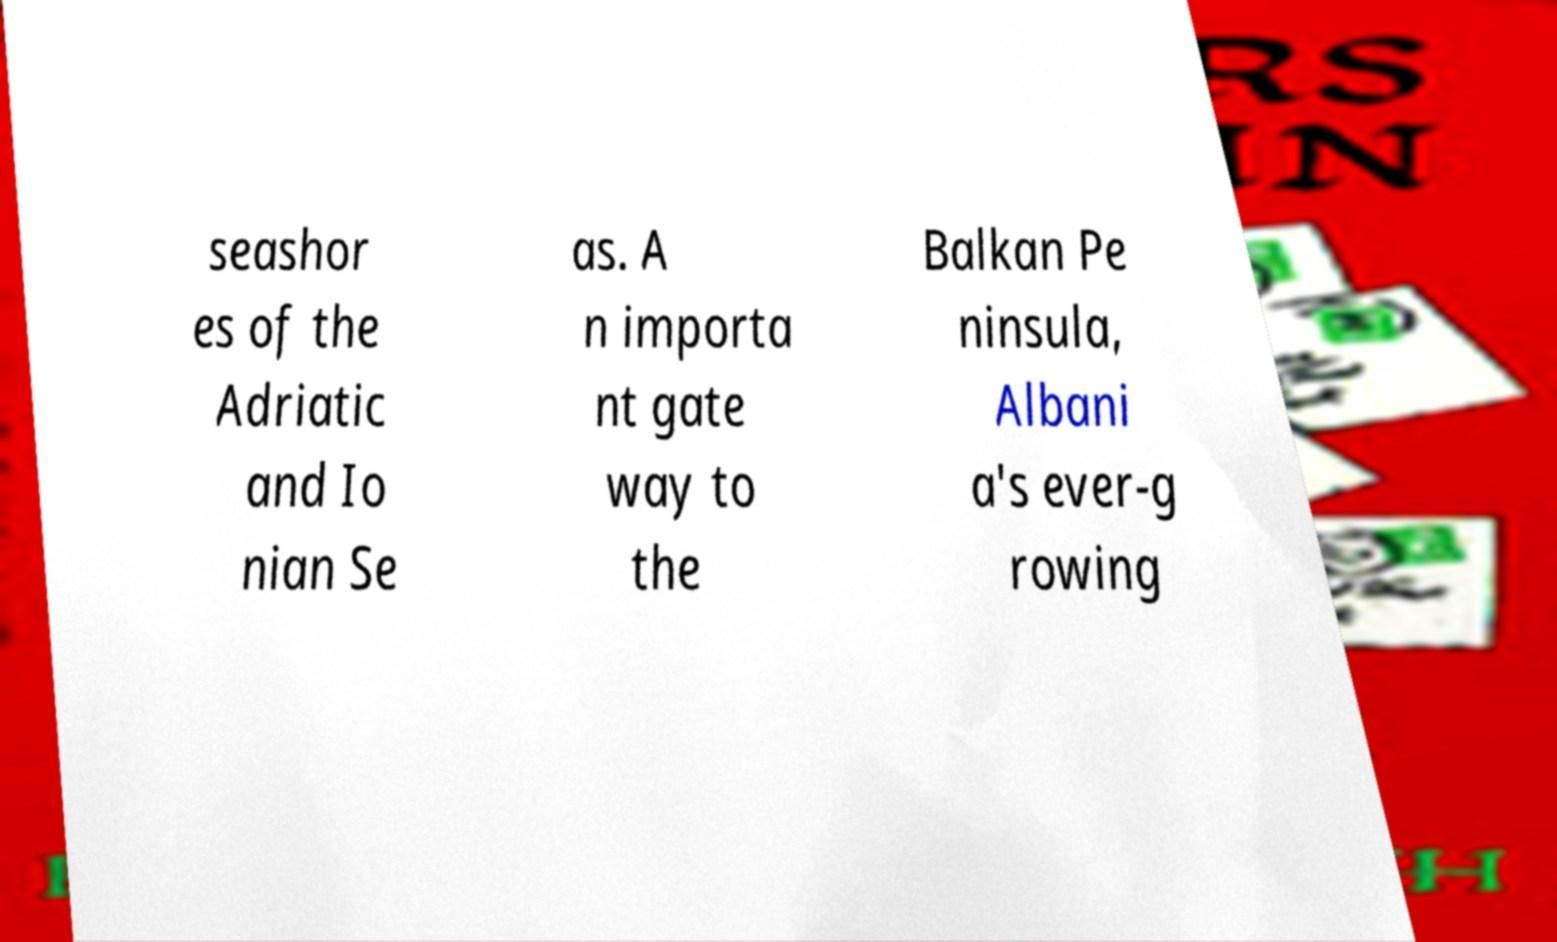Please read and relay the text visible in this image. What does it say? seashor es of the Adriatic and Io nian Se as. A n importa nt gate way to the Balkan Pe ninsula, Albani a's ever-g rowing 